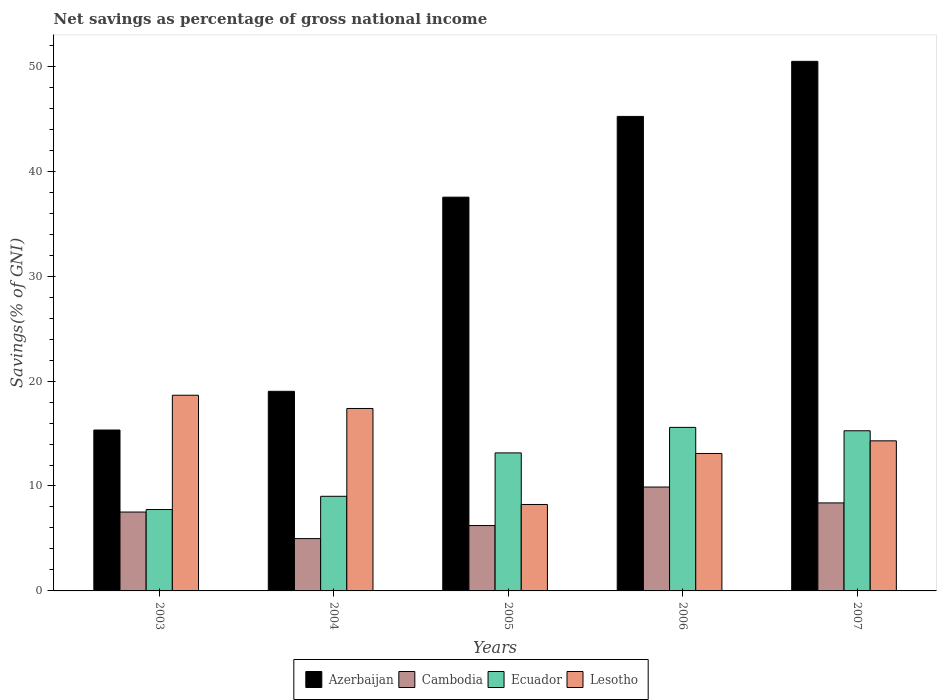Are the number of bars per tick equal to the number of legend labels?
Provide a succinct answer. Yes. Are the number of bars on each tick of the X-axis equal?
Give a very brief answer. Yes. How many bars are there on the 3rd tick from the right?
Your response must be concise. 4. In how many cases, is the number of bars for a given year not equal to the number of legend labels?
Your answer should be very brief. 0. What is the total savings in Azerbaijan in 2005?
Offer a terse response. 37.52. Across all years, what is the maximum total savings in Azerbaijan?
Offer a very short reply. 50.47. Across all years, what is the minimum total savings in Azerbaijan?
Your answer should be very brief. 15.33. In which year was the total savings in Cambodia maximum?
Your response must be concise. 2006. What is the total total savings in Azerbaijan in the graph?
Give a very brief answer. 167.57. What is the difference between the total savings in Lesotho in 2004 and that in 2006?
Your response must be concise. 4.29. What is the difference between the total savings in Azerbaijan in 2005 and the total savings in Ecuador in 2004?
Give a very brief answer. 28.51. What is the average total savings in Ecuador per year?
Offer a terse response. 12.16. In the year 2007, what is the difference between the total savings in Azerbaijan and total savings in Lesotho?
Make the answer very short. 36.16. In how many years, is the total savings in Azerbaijan greater than 12 %?
Provide a succinct answer. 5. What is the ratio of the total savings in Cambodia in 2005 to that in 2007?
Provide a short and direct response. 0.74. Is the total savings in Cambodia in 2005 less than that in 2007?
Offer a terse response. Yes. Is the difference between the total savings in Azerbaijan in 2003 and 2006 greater than the difference between the total savings in Lesotho in 2003 and 2006?
Offer a very short reply. No. What is the difference between the highest and the second highest total savings in Cambodia?
Offer a terse response. 1.51. What is the difference between the highest and the lowest total savings in Cambodia?
Your answer should be compact. 4.91. What does the 3rd bar from the left in 2005 represents?
Offer a very short reply. Ecuador. What does the 4th bar from the right in 2006 represents?
Offer a terse response. Azerbaijan. Is it the case that in every year, the sum of the total savings in Azerbaijan and total savings in Ecuador is greater than the total savings in Cambodia?
Make the answer very short. Yes. How many bars are there?
Offer a terse response. 20. What is the difference between two consecutive major ticks on the Y-axis?
Provide a succinct answer. 10. Are the values on the major ticks of Y-axis written in scientific E-notation?
Ensure brevity in your answer.  No. Does the graph contain any zero values?
Offer a very short reply. No. Does the graph contain grids?
Ensure brevity in your answer.  No. What is the title of the graph?
Your response must be concise. Net savings as percentage of gross national income. What is the label or title of the X-axis?
Ensure brevity in your answer.  Years. What is the label or title of the Y-axis?
Offer a terse response. Savings(% of GNI). What is the Savings(% of GNI) in Azerbaijan in 2003?
Provide a succinct answer. 15.33. What is the Savings(% of GNI) of Cambodia in 2003?
Keep it short and to the point. 7.52. What is the Savings(% of GNI) of Ecuador in 2003?
Provide a succinct answer. 7.76. What is the Savings(% of GNI) of Lesotho in 2003?
Offer a very short reply. 18.65. What is the Savings(% of GNI) in Azerbaijan in 2004?
Ensure brevity in your answer.  19.02. What is the Savings(% of GNI) of Cambodia in 2004?
Ensure brevity in your answer.  4.99. What is the Savings(% of GNI) in Ecuador in 2004?
Offer a terse response. 9.02. What is the Savings(% of GNI) of Lesotho in 2004?
Give a very brief answer. 17.39. What is the Savings(% of GNI) in Azerbaijan in 2005?
Keep it short and to the point. 37.52. What is the Savings(% of GNI) in Cambodia in 2005?
Give a very brief answer. 6.23. What is the Savings(% of GNI) of Ecuador in 2005?
Your response must be concise. 13.15. What is the Savings(% of GNI) in Lesotho in 2005?
Offer a very short reply. 8.24. What is the Savings(% of GNI) of Azerbaijan in 2006?
Make the answer very short. 45.22. What is the Savings(% of GNI) of Cambodia in 2006?
Your answer should be very brief. 9.9. What is the Savings(% of GNI) in Ecuador in 2006?
Make the answer very short. 15.58. What is the Savings(% of GNI) of Lesotho in 2006?
Give a very brief answer. 13.1. What is the Savings(% of GNI) of Azerbaijan in 2007?
Offer a very short reply. 50.47. What is the Savings(% of GNI) of Cambodia in 2007?
Offer a very short reply. 8.39. What is the Savings(% of GNI) of Ecuador in 2007?
Your response must be concise. 15.26. What is the Savings(% of GNI) of Lesotho in 2007?
Your response must be concise. 14.3. Across all years, what is the maximum Savings(% of GNI) of Azerbaijan?
Offer a terse response. 50.47. Across all years, what is the maximum Savings(% of GNI) in Cambodia?
Your response must be concise. 9.9. Across all years, what is the maximum Savings(% of GNI) in Ecuador?
Ensure brevity in your answer.  15.58. Across all years, what is the maximum Savings(% of GNI) of Lesotho?
Your response must be concise. 18.65. Across all years, what is the minimum Savings(% of GNI) of Azerbaijan?
Your answer should be compact. 15.33. Across all years, what is the minimum Savings(% of GNI) in Cambodia?
Make the answer very short. 4.99. Across all years, what is the minimum Savings(% of GNI) of Ecuador?
Make the answer very short. 7.76. Across all years, what is the minimum Savings(% of GNI) of Lesotho?
Provide a succinct answer. 8.24. What is the total Savings(% of GNI) of Azerbaijan in the graph?
Ensure brevity in your answer.  167.57. What is the total Savings(% of GNI) in Cambodia in the graph?
Provide a succinct answer. 37.02. What is the total Savings(% of GNI) of Ecuador in the graph?
Offer a terse response. 60.78. What is the total Savings(% of GNI) of Lesotho in the graph?
Offer a terse response. 71.68. What is the difference between the Savings(% of GNI) in Azerbaijan in 2003 and that in 2004?
Keep it short and to the point. -3.69. What is the difference between the Savings(% of GNI) of Cambodia in 2003 and that in 2004?
Give a very brief answer. 2.53. What is the difference between the Savings(% of GNI) of Ecuador in 2003 and that in 2004?
Provide a succinct answer. -1.26. What is the difference between the Savings(% of GNI) of Lesotho in 2003 and that in 2004?
Make the answer very short. 1.26. What is the difference between the Savings(% of GNI) of Azerbaijan in 2003 and that in 2005?
Provide a succinct answer. -22.19. What is the difference between the Savings(% of GNI) in Cambodia in 2003 and that in 2005?
Provide a short and direct response. 1.29. What is the difference between the Savings(% of GNI) in Ecuador in 2003 and that in 2005?
Offer a terse response. -5.4. What is the difference between the Savings(% of GNI) in Lesotho in 2003 and that in 2005?
Your answer should be compact. 10.41. What is the difference between the Savings(% of GNI) of Azerbaijan in 2003 and that in 2006?
Ensure brevity in your answer.  -29.89. What is the difference between the Savings(% of GNI) in Cambodia in 2003 and that in 2006?
Your answer should be very brief. -2.38. What is the difference between the Savings(% of GNI) of Ecuador in 2003 and that in 2006?
Provide a short and direct response. -7.83. What is the difference between the Savings(% of GNI) in Lesotho in 2003 and that in 2006?
Give a very brief answer. 5.55. What is the difference between the Savings(% of GNI) of Azerbaijan in 2003 and that in 2007?
Offer a very short reply. -35.13. What is the difference between the Savings(% of GNI) of Cambodia in 2003 and that in 2007?
Provide a short and direct response. -0.87. What is the difference between the Savings(% of GNI) in Ecuador in 2003 and that in 2007?
Offer a terse response. -7.51. What is the difference between the Savings(% of GNI) in Lesotho in 2003 and that in 2007?
Your answer should be very brief. 4.34. What is the difference between the Savings(% of GNI) in Azerbaijan in 2004 and that in 2005?
Offer a very short reply. -18.5. What is the difference between the Savings(% of GNI) of Cambodia in 2004 and that in 2005?
Your answer should be very brief. -1.24. What is the difference between the Savings(% of GNI) of Ecuador in 2004 and that in 2005?
Make the answer very short. -4.13. What is the difference between the Savings(% of GNI) of Lesotho in 2004 and that in 2005?
Keep it short and to the point. 9.15. What is the difference between the Savings(% of GNI) of Azerbaijan in 2004 and that in 2006?
Keep it short and to the point. -26.2. What is the difference between the Savings(% of GNI) of Cambodia in 2004 and that in 2006?
Offer a terse response. -4.91. What is the difference between the Savings(% of GNI) in Ecuador in 2004 and that in 2006?
Your answer should be compact. -6.57. What is the difference between the Savings(% of GNI) in Lesotho in 2004 and that in 2006?
Your answer should be compact. 4.29. What is the difference between the Savings(% of GNI) of Azerbaijan in 2004 and that in 2007?
Your answer should be very brief. -31.45. What is the difference between the Savings(% of GNI) in Cambodia in 2004 and that in 2007?
Your response must be concise. -3.4. What is the difference between the Savings(% of GNI) in Ecuador in 2004 and that in 2007?
Offer a very short reply. -6.24. What is the difference between the Savings(% of GNI) in Lesotho in 2004 and that in 2007?
Offer a terse response. 3.08. What is the difference between the Savings(% of GNI) in Azerbaijan in 2005 and that in 2006?
Provide a succinct answer. -7.7. What is the difference between the Savings(% of GNI) in Cambodia in 2005 and that in 2006?
Your answer should be very brief. -3.67. What is the difference between the Savings(% of GNI) of Ecuador in 2005 and that in 2006?
Provide a short and direct response. -2.43. What is the difference between the Savings(% of GNI) of Lesotho in 2005 and that in 2006?
Offer a very short reply. -4.86. What is the difference between the Savings(% of GNI) of Azerbaijan in 2005 and that in 2007?
Make the answer very short. -12.94. What is the difference between the Savings(% of GNI) of Cambodia in 2005 and that in 2007?
Offer a terse response. -2.16. What is the difference between the Savings(% of GNI) of Ecuador in 2005 and that in 2007?
Provide a short and direct response. -2.11. What is the difference between the Savings(% of GNI) in Lesotho in 2005 and that in 2007?
Provide a succinct answer. -6.07. What is the difference between the Savings(% of GNI) in Azerbaijan in 2006 and that in 2007?
Give a very brief answer. -5.25. What is the difference between the Savings(% of GNI) of Cambodia in 2006 and that in 2007?
Your answer should be very brief. 1.51. What is the difference between the Savings(% of GNI) in Ecuador in 2006 and that in 2007?
Ensure brevity in your answer.  0.32. What is the difference between the Savings(% of GNI) of Lesotho in 2006 and that in 2007?
Provide a succinct answer. -1.2. What is the difference between the Savings(% of GNI) in Azerbaijan in 2003 and the Savings(% of GNI) in Cambodia in 2004?
Your response must be concise. 10.35. What is the difference between the Savings(% of GNI) of Azerbaijan in 2003 and the Savings(% of GNI) of Ecuador in 2004?
Your response must be concise. 6.32. What is the difference between the Savings(% of GNI) of Azerbaijan in 2003 and the Savings(% of GNI) of Lesotho in 2004?
Give a very brief answer. -2.05. What is the difference between the Savings(% of GNI) in Cambodia in 2003 and the Savings(% of GNI) in Ecuador in 2004?
Offer a very short reply. -1.5. What is the difference between the Savings(% of GNI) in Cambodia in 2003 and the Savings(% of GNI) in Lesotho in 2004?
Make the answer very short. -9.87. What is the difference between the Savings(% of GNI) of Ecuador in 2003 and the Savings(% of GNI) of Lesotho in 2004?
Provide a short and direct response. -9.63. What is the difference between the Savings(% of GNI) of Azerbaijan in 2003 and the Savings(% of GNI) of Cambodia in 2005?
Give a very brief answer. 9.1. What is the difference between the Savings(% of GNI) in Azerbaijan in 2003 and the Savings(% of GNI) in Ecuador in 2005?
Your answer should be very brief. 2.18. What is the difference between the Savings(% of GNI) in Azerbaijan in 2003 and the Savings(% of GNI) in Lesotho in 2005?
Offer a very short reply. 7.1. What is the difference between the Savings(% of GNI) of Cambodia in 2003 and the Savings(% of GNI) of Ecuador in 2005?
Keep it short and to the point. -5.64. What is the difference between the Savings(% of GNI) in Cambodia in 2003 and the Savings(% of GNI) in Lesotho in 2005?
Offer a terse response. -0.72. What is the difference between the Savings(% of GNI) of Ecuador in 2003 and the Savings(% of GNI) of Lesotho in 2005?
Offer a terse response. -0.48. What is the difference between the Savings(% of GNI) in Azerbaijan in 2003 and the Savings(% of GNI) in Cambodia in 2006?
Offer a terse response. 5.43. What is the difference between the Savings(% of GNI) in Azerbaijan in 2003 and the Savings(% of GNI) in Ecuador in 2006?
Your answer should be very brief. -0.25. What is the difference between the Savings(% of GNI) in Azerbaijan in 2003 and the Savings(% of GNI) in Lesotho in 2006?
Ensure brevity in your answer.  2.23. What is the difference between the Savings(% of GNI) of Cambodia in 2003 and the Savings(% of GNI) of Ecuador in 2006?
Offer a terse response. -8.07. What is the difference between the Savings(% of GNI) in Cambodia in 2003 and the Savings(% of GNI) in Lesotho in 2006?
Provide a succinct answer. -5.58. What is the difference between the Savings(% of GNI) of Ecuador in 2003 and the Savings(% of GNI) of Lesotho in 2006?
Offer a very short reply. -5.34. What is the difference between the Savings(% of GNI) of Azerbaijan in 2003 and the Savings(% of GNI) of Cambodia in 2007?
Offer a very short reply. 6.95. What is the difference between the Savings(% of GNI) of Azerbaijan in 2003 and the Savings(% of GNI) of Ecuador in 2007?
Your response must be concise. 0.07. What is the difference between the Savings(% of GNI) of Azerbaijan in 2003 and the Savings(% of GNI) of Lesotho in 2007?
Your answer should be compact. 1.03. What is the difference between the Savings(% of GNI) in Cambodia in 2003 and the Savings(% of GNI) in Ecuador in 2007?
Offer a terse response. -7.75. What is the difference between the Savings(% of GNI) of Cambodia in 2003 and the Savings(% of GNI) of Lesotho in 2007?
Your answer should be compact. -6.79. What is the difference between the Savings(% of GNI) in Ecuador in 2003 and the Savings(% of GNI) in Lesotho in 2007?
Provide a succinct answer. -6.55. What is the difference between the Savings(% of GNI) of Azerbaijan in 2004 and the Savings(% of GNI) of Cambodia in 2005?
Offer a very short reply. 12.79. What is the difference between the Savings(% of GNI) in Azerbaijan in 2004 and the Savings(% of GNI) in Ecuador in 2005?
Provide a short and direct response. 5.87. What is the difference between the Savings(% of GNI) of Azerbaijan in 2004 and the Savings(% of GNI) of Lesotho in 2005?
Provide a short and direct response. 10.78. What is the difference between the Savings(% of GNI) of Cambodia in 2004 and the Savings(% of GNI) of Ecuador in 2005?
Offer a very short reply. -8.17. What is the difference between the Savings(% of GNI) in Cambodia in 2004 and the Savings(% of GNI) in Lesotho in 2005?
Keep it short and to the point. -3.25. What is the difference between the Savings(% of GNI) in Ecuador in 2004 and the Savings(% of GNI) in Lesotho in 2005?
Keep it short and to the point. 0.78. What is the difference between the Savings(% of GNI) of Azerbaijan in 2004 and the Savings(% of GNI) of Cambodia in 2006?
Your response must be concise. 9.12. What is the difference between the Savings(% of GNI) in Azerbaijan in 2004 and the Savings(% of GNI) in Ecuador in 2006?
Keep it short and to the point. 3.44. What is the difference between the Savings(% of GNI) of Azerbaijan in 2004 and the Savings(% of GNI) of Lesotho in 2006?
Give a very brief answer. 5.92. What is the difference between the Savings(% of GNI) in Cambodia in 2004 and the Savings(% of GNI) in Ecuador in 2006?
Ensure brevity in your answer.  -10.6. What is the difference between the Savings(% of GNI) of Cambodia in 2004 and the Savings(% of GNI) of Lesotho in 2006?
Your answer should be very brief. -8.11. What is the difference between the Savings(% of GNI) of Ecuador in 2004 and the Savings(% of GNI) of Lesotho in 2006?
Your answer should be very brief. -4.08. What is the difference between the Savings(% of GNI) of Azerbaijan in 2004 and the Savings(% of GNI) of Cambodia in 2007?
Your response must be concise. 10.64. What is the difference between the Savings(% of GNI) in Azerbaijan in 2004 and the Savings(% of GNI) in Ecuador in 2007?
Provide a short and direct response. 3.76. What is the difference between the Savings(% of GNI) of Azerbaijan in 2004 and the Savings(% of GNI) of Lesotho in 2007?
Keep it short and to the point. 4.72. What is the difference between the Savings(% of GNI) of Cambodia in 2004 and the Savings(% of GNI) of Ecuador in 2007?
Ensure brevity in your answer.  -10.28. What is the difference between the Savings(% of GNI) in Cambodia in 2004 and the Savings(% of GNI) in Lesotho in 2007?
Your answer should be very brief. -9.32. What is the difference between the Savings(% of GNI) in Ecuador in 2004 and the Savings(% of GNI) in Lesotho in 2007?
Provide a succinct answer. -5.29. What is the difference between the Savings(% of GNI) of Azerbaijan in 2005 and the Savings(% of GNI) of Cambodia in 2006?
Keep it short and to the point. 27.62. What is the difference between the Savings(% of GNI) in Azerbaijan in 2005 and the Savings(% of GNI) in Ecuador in 2006?
Keep it short and to the point. 21.94. What is the difference between the Savings(% of GNI) of Azerbaijan in 2005 and the Savings(% of GNI) of Lesotho in 2006?
Provide a succinct answer. 24.43. What is the difference between the Savings(% of GNI) of Cambodia in 2005 and the Savings(% of GNI) of Ecuador in 2006?
Make the answer very short. -9.36. What is the difference between the Savings(% of GNI) of Cambodia in 2005 and the Savings(% of GNI) of Lesotho in 2006?
Provide a short and direct response. -6.87. What is the difference between the Savings(% of GNI) in Ecuador in 2005 and the Savings(% of GNI) in Lesotho in 2006?
Give a very brief answer. 0.05. What is the difference between the Savings(% of GNI) of Azerbaijan in 2005 and the Savings(% of GNI) of Cambodia in 2007?
Offer a very short reply. 29.14. What is the difference between the Savings(% of GNI) of Azerbaijan in 2005 and the Savings(% of GNI) of Ecuador in 2007?
Ensure brevity in your answer.  22.26. What is the difference between the Savings(% of GNI) in Azerbaijan in 2005 and the Savings(% of GNI) in Lesotho in 2007?
Offer a very short reply. 23.22. What is the difference between the Savings(% of GNI) in Cambodia in 2005 and the Savings(% of GNI) in Ecuador in 2007?
Your answer should be very brief. -9.03. What is the difference between the Savings(% of GNI) in Cambodia in 2005 and the Savings(% of GNI) in Lesotho in 2007?
Make the answer very short. -8.07. What is the difference between the Savings(% of GNI) of Ecuador in 2005 and the Savings(% of GNI) of Lesotho in 2007?
Your response must be concise. -1.15. What is the difference between the Savings(% of GNI) of Azerbaijan in 2006 and the Savings(% of GNI) of Cambodia in 2007?
Give a very brief answer. 36.83. What is the difference between the Savings(% of GNI) of Azerbaijan in 2006 and the Savings(% of GNI) of Ecuador in 2007?
Your answer should be very brief. 29.96. What is the difference between the Savings(% of GNI) of Azerbaijan in 2006 and the Savings(% of GNI) of Lesotho in 2007?
Offer a terse response. 30.92. What is the difference between the Savings(% of GNI) of Cambodia in 2006 and the Savings(% of GNI) of Ecuador in 2007?
Your answer should be compact. -5.36. What is the difference between the Savings(% of GNI) in Cambodia in 2006 and the Savings(% of GNI) in Lesotho in 2007?
Provide a succinct answer. -4.4. What is the difference between the Savings(% of GNI) in Ecuador in 2006 and the Savings(% of GNI) in Lesotho in 2007?
Give a very brief answer. 1.28. What is the average Savings(% of GNI) in Azerbaijan per year?
Provide a succinct answer. 33.51. What is the average Savings(% of GNI) in Cambodia per year?
Make the answer very short. 7.4. What is the average Savings(% of GNI) in Ecuador per year?
Ensure brevity in your answer.  12.16. What is the average Savings(% of GNI) of Lesotho per year?
Provide a succinct answer. 14.34. In the year 2003, what is the difference between the Savings(% of GNI) of Azerbaijan and Savings(% of GNI) of Cambodia?
Your answer should be compact. 7.82. In the year 2003, what is the difference between the Savings(% of GNI) in Azerbaijan and Savings(% of GNI) in Ecuador?
Provide a short and direct response. 7.58. In the year 2003, what is the difference between the Savings(% of GNI) of Azerbaijan and Savings(% of GNI) of Lesotho?
Provide a short and direct response. -3.31. In the year 2003, what is the difference between the Savings(% of GNI) in Cambodia and Savings(% of GNI) in Ecuador?
Provide a short and direct response. -0.24. In the year 2003, what is the difference between the Savings(% of GNI) of Cambodia and Savings(% of GNI) of Lesotho?
Make the answer very short. -11.13. In the year 2003, what is the difference between the Savings(% of GNI) of Ecuador and Savings(% of GNI) of Lesotho?
Your answer should be compact. -10.89. In the year 2004, what is the difference between the Savings(% of GNI) in Azerbaijan and Savings(% of GNI) in Cambodia?
Offer a very short reply. 14.04. In the year 2004, what is the difference between the Savings(% of GNI) in Azerbaijan and Savings(% of GNI) in Ecuador?
Your answer should be compact. 10. In the year 2004, what is the difference between the Savings(% of GNI) of Azerbaijan and Savings(% of GNI) of Lesotho?
Provide a short and direct response. 1.64. In the year 2004, what is the difference between the Savings(% of GNI) of Cambodia and Savings(% of GNI) of Ecuador?
Provide a short and direct response. -4.03. In the year 2004, what is the difference between the Savings(% of GNI) of Cambodia and Savings(% of GNI) of Lesotho?
Offer a very short reply. -12.4. In the year 2004, what is the difference between the Savings(% of GNI) of Ecuador and Savings(% of GNI) of Lesotho?
Offer a terse response. -8.37. In the year 2005, what is the difference between the Savings(% of GNI) of Azerbaijan and Savings(% of GNI) of Cambodia?
Your answer should be compact. 31.3. In the year 2005, what is the difference between the Savings(% of GNI) in Azerbaijan and Savings(% of GNI) in Ecuador?
Keep it short and to the point. 24.37. In the year 2005, what is the difference between the Savings(% of GNI) in Azerbaijan and Savings(% of GNI) in Lesotho?
Your answer should be compact. 29.29. In the year 2005, what is the difference between the Savings(% of GNI) in Cambodia and Savings(% of GNI) in Ecuador?
Give a very brief answer. -6.92. In the year 2005, what is the difference between the Savings(% of GNI) of Cambodia and Savings(% of GNI) of Lesotho?
Your response must be concise. -2.01. In the year 2005, what is the difference between the Savings(% of GNI) in Ecuador and Savings(% of GNI) in Lesotho?
Your answer should be very brief. 4.91. In the year 2006, what is the difference between the Savings(% of GNI) in Azerbaijan and Savings(% of GNI) in Cambodia?
Your answer should be compact. 35.32. In the year 2006, what is the difference between the Savings(% of GNI) in Azerbaijan and Savings(% of GNI) in Ecuador?
Offer a very short reply. 29.64. In the year 2006, what is the difference between the Savings(% of GNI) of Azerbaijan and Savings(% of GNI) of Lesotho?
Provide a short and direct response. 32.12. In the year 2006, what is the difference between the Savings(% of GNI) of Cambodia and Savings(% of GNI) of Ecuador?
Give a very brief answer. -5.68. In the year 2006, what is the difference between the Savings(% of GNI) of Cambodia and Savings(% of GNI) of Lesotho?
Your answer should be compact. -3.2. In the year 2006, what is the difference between the Savings(% of GNI) in Ecuador and Savings(% of GNI) in Lesotho?
Provide a succinct answer. 2.49. In the year 2007, what is the difference between the Savings(% of GNI) of Azerbaijan and Savings(% of GNI) of Cambodia?
Keep it short and to the point. 42.08. In the year 2007, what is the difference between the Savings(% of GNI) of Azerbaijan and Savings(% of GNI) of Ecuador?
Your response must be concise. 35.21. In the year 2007, what is the difference between the Savings(% of GNI) of Azerbaijan and Savings(% of GNI) of Lesotho?
Make the answer very short. 36.16. In the year 2007, what is the difference between the Savings(% of GNI) in Cambodia and Savings(% of GNI) in Ecuador?
Offer a very short reply. -6.88. In the year 2007, what is the difference between the Savings(% of GNI) in Cambodia and Savings(% of GNI) in Lesotho?
Keep it short and to the point. -5.92. In the year 2007, what is the difference between the Savings(% of GNI) in Ecuador and Savings(% of GNI) in Lesotho?
Make the answer very short. 0.96. What is the ratio of the Savings(% of GNI) in Azerbaijan in 2003 to that in 2004?
Provide a succinct answer. 0.81. What is the ratio of the Savings(% of GNI) in Cambodia in 2003 to that in 2004?
Offer a terse response. 1.51. What is the ratio of the Savings(% of GNI) in Ecuador in 2003 to that in 2004?
Offer a terse response. 0.86. What is the ratio of the Savings(% of GNI) of Lesotho in 2003 to that in 2004?
Your answer should be compact. 1.07. What is the ratio of the Savings(% of GNI) of Azerbaijan in 2003 to that in 2005?
Your response must be concise. 0.41. What is the ratio of the Savings(% of GNI) of Cambodia in 2003 to that in 2005?
Your answer should be compact. 1.21. What is the ratio of the Savings(% of GNI) in Ecuador in 2003 to that in 2005?
Your answer should be very brief. 0.59. What is the ratio of the Savings(% of GNI) in Lesotho in 2003 to that in 2005?
Keep it short and to the point. 2.26. What is the ratio of the Savings(% of GNI) of Azerbaijan in 2003 to that in 2006?
Your response must be concise. 0.34. What is the ratio of the Savings(% of GNI) in Cambodia in 2003 to that in 2006?
Offer a terse response. 0.76. What is the ratio of the Savings(% of GNI) in Ecuador in 2003 to that in 2006?
Give a very brief answer. 0.5. What is the ratio of the Savings(% of GNI) in Lesotho in 2003 to that in 2006?
Offer a terse response. 1.42. What is the ratio of the Savings(% of GNI) in Azerbaijan in 2003 to that in 2007?
Provide a succinct answer. 0.3. What is the ratio of the Savings(% of GNI) in Cambodia in 2003 to that in 2007?
Provide a succinct answer. 0.9. What is the ratio of the Savings(% of GNI) of Ecuador in 2003 to that in 2007?
Your answer should be compact. 0.51. What is the ratio of the Savings(% of GNI) in Lesotho in 2003 to that in 2007?
Your response must be concise. 1.3. What is the ratio of the Savings(% of GNI) of Azerbaijan in 2004 to that in 2005?
Your answer should be compact. 0.51. What is the ratio of the Savings(% of GNI) of Cambodia in 2004 to that in 2005?
Give a very brief answer. 0.8. What is the ratio of the Savings(% of GNI) in Ecuador in 2004 to that in 2005?
Provide a short and direct response. 0.69. What is the ratio of the Savings(% of GNI) of Lesotho in 2004 to that in 2005?
Give a very brief answer. 2.11. What is the ratio of the Savings(% of GNI) of Azerbaijan in 2004 to that in 2006?
Your answer should be very brief. 0.42. What is the ratio of the Savings(% of GNI) in Cambodia in 2004 to that in 2006?
Make the answer very short. 0.5. What is the ratio of the Savings(% of GNI) of Ecuador in 2004 to that in 2006?
Provide a short and direct response. 0.58. What is the ratio of the Savings(% of GNI) in Lesotho in 2004 to that in 2006?
Make the answer very short. 1.33. What is the ratio of the Savings(% of GNI) in Azerbaijan in 2004 to that in 2007?
Make the answer very short. 0.38. What is the ratio of the Savings(% of GNI) in Cambodia in 2004 to that in 2007?
Give a very brief answer. 0.59. What is the ratio of the Savings(% of GNI) in Ecuador in 2004 to that in 2007?
Your response must be concise. 0.59. What is the ratio of the Savings(% of GNI) in Lesotho in 2004 to that in 2007?
Ensure brevity in your answer.  1.22. What is the ratio of the Savings(% of GNI) of Azerbaijan in 2005 to that in 2006?
Offer a terse response. 0.83. What is the ratio of the Savings(% of GNI) in Cambodia in 2005 to that in 2006?
Provide a short and direct response. 0.63. What is the ratio of the Savings(% of GNI) of Ecuador in 2005 to that in 2006?
Ensure brevity in your answer.  0.84. What is the ratio of the Savings(% of GNI) of Lesotho in 2005 to that in 2006?
Your response must be concise. 0.63. What is the ratio of the Savings(% of GNI) in Azerbaijan in 2005 to that in 2007?
Your response must be concise. 0.74. What is the ratio of the Savings(% of GNI) in Cambodia in 2005 to that in 2007?
Provide a succinct answer. 0.74. What is the ratio of the Savings(% of GNI) in Ecuador in 2005 to that in 2007?
Give a very brief answer. 0.86. What is the ratio of the Savings(% of GNI) of Lesotho in 2005 to that in 2007?
Your answer should be compact. 0.58. What is the ratio of the Savings(% of GNI) of Azerbaijan in 2006 to that in 2007?
Ensure brevity in your answer.  0.9. What is the ratio of the Savings(% of GNI) of Cambodia in 2006 to that in 2007?
Give a very brief answer. 1.18. What is the ratio of the Savings(% of GNI) in Ecuador in 2006 to that in 2007?
Give a very brief answer. 1.02. What is the ratio of the Savings(% of GNI) in Lesotho in 2006 to that in 2007?
Make the answer very short. 0.92. What is the difference between the highest and the second highest Savings(% of GNI) in Azerbaijan?
Provide a short and direct response. 5.25. What is the difference between the highest and the second highest Savings(% of GNI) of Cambodia?
Your answer should be compact. 1.51. What is the difference between the highest and the second highest Savings(% of GNI) in Ecuador?
Your response must be concise. 0.32. What is the difference between the highest and the second highest Savings(% of GNI) in Lesotho?
Your response must be concise. 1.26. What is the difference between the highest and the lowest Savings(% of GNI) in Azerbaijan?
Keep it short and to the point. 35.13. What is the difference between the highest and the lowest Savings(% of GNI) in Cambodia?
Your answer should be compact. 4.91. What is the difference between the highest and the lowest Savings(% of GNI) of Ecuador?
Provide a short and direct response. 7.83. What is the difference between the highest and the lowest Savings(% of GNI) of Lesotho?
Your answer should be compact. 10.41. 